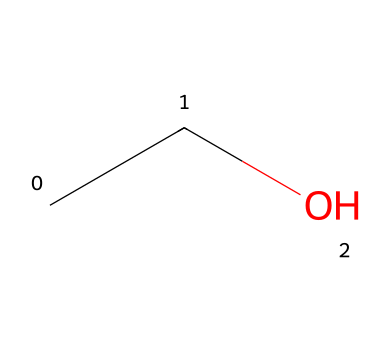What is the common name of the chemical represented by this structure? The SMILES representation "CCO" corresponds to ethanol. Ethanol is commonly known by its IUPAC name and is popularly referred to as alcohol.
Answer: ethanol How many carbon atoms are present in this chemical structure? The SMILES "CCO" indicates there are two carbon atoms connected together in the chemical structure. Each "C" in the SMILES represents one carbon atom.
Answer: 2 What type of functional group is present in this chemical? The structure "CCO" includes an -OH group (hydroxyl group) attached to a carbon chain, which is characteristic of alcohols. Hence, this indicates the presence of a hydroxyl functional group.
Answer: hydroxyl Is this compound polar or nonpolar? Ethanol has a polar -OH (hydroxyl) group, which makes the entire molecule polar. The presence of this polar functional group results in the molecule having higher solubility in water compared to nonpolar substances.
Answer: polar What is the primary use of this compound in automotive applications? Ethanol is commonly used in automotive windshield washer fluid as a solvent or cleaning agent. It helps dissolve dirt and grime on windshields effectively due to its properties.
Answer: solvent 